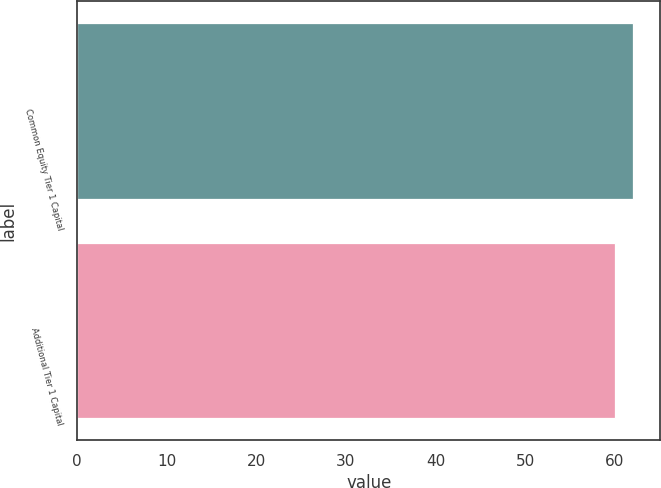Convert chart to OTSL. <chart><loc_0><loc_0><loc_500><loc_500><bar_chart><fcel>Common Equity Tier 1 Capital<fcel>Additional Tier 1 Capital<nl><fcel>62<fcel>60<nl></chart> 